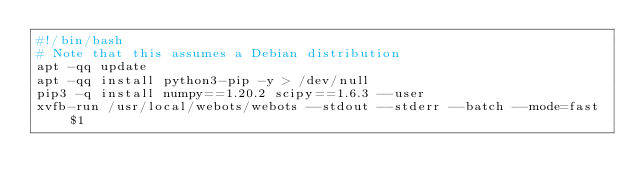Convert code to text. <code><loc_0><loc_0><loc_500><loc_500><_Bash_>#!/bin/bash
# Note that this assumes a Debian distribution
apt -qq update
apt -qq install python3-pip -y > /dev/null
pip3 -q install numpy==1.20.2 scipy==1.6.3 --user
xvfb-run /usr/local/webots/webots --stdout --stderr --batch --mode=fast $1
</code> 